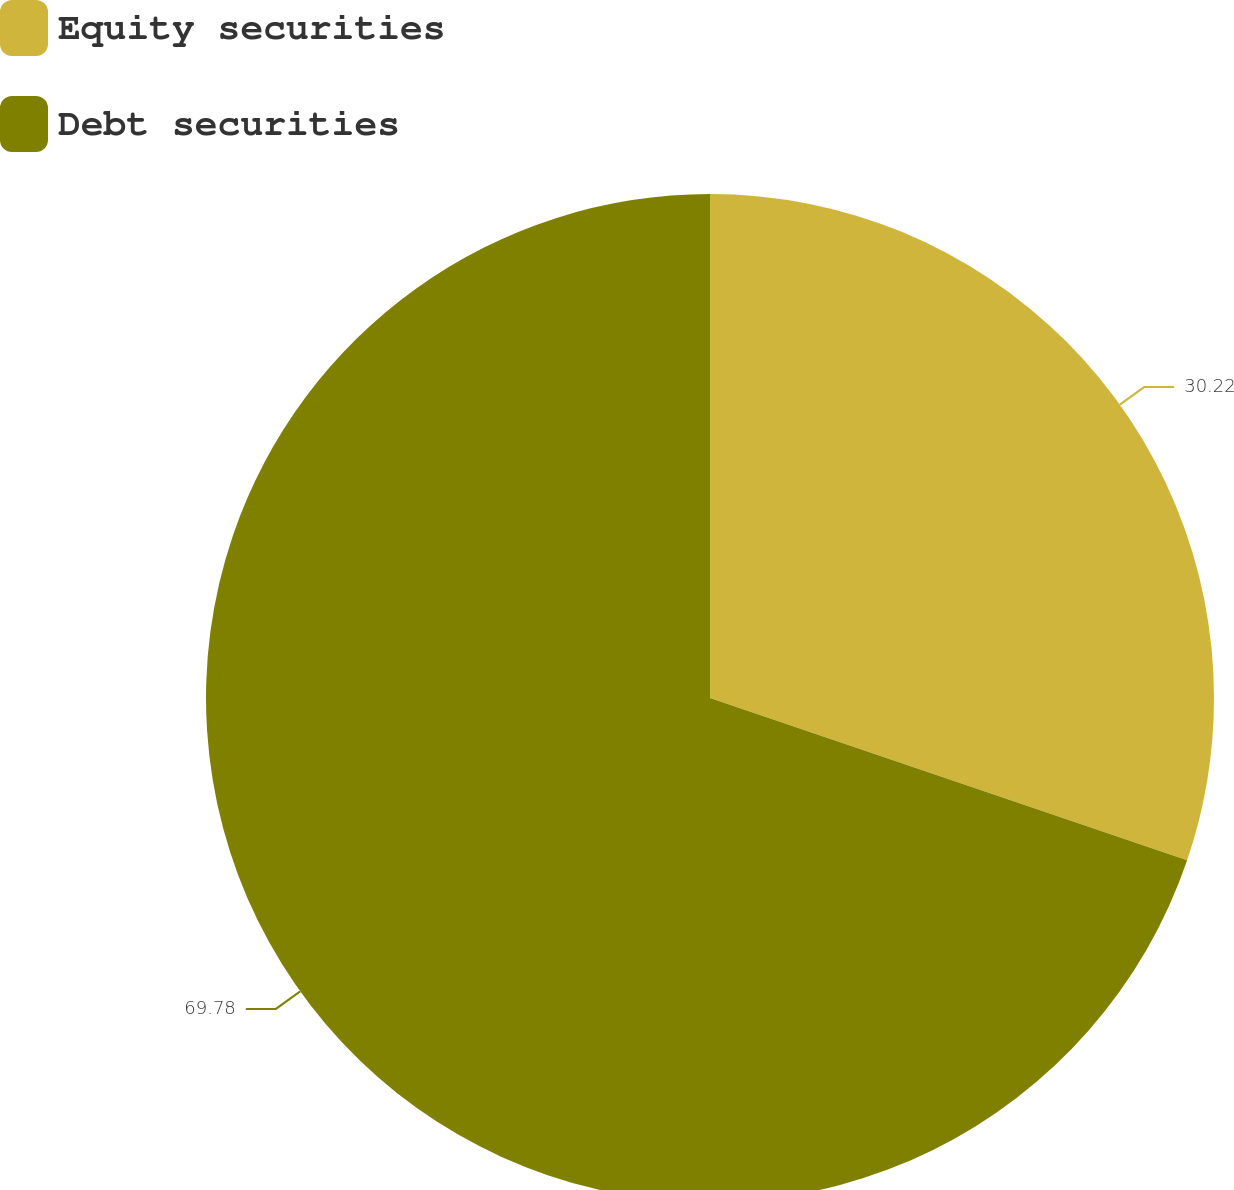<chart> <loc_0><loc_0><loc_500><loc_500><pie_chart><fcel>Equity securities<fcel>Debt securities<nl><fcel>30.22%<fcel>69.78%<nl></chart> 